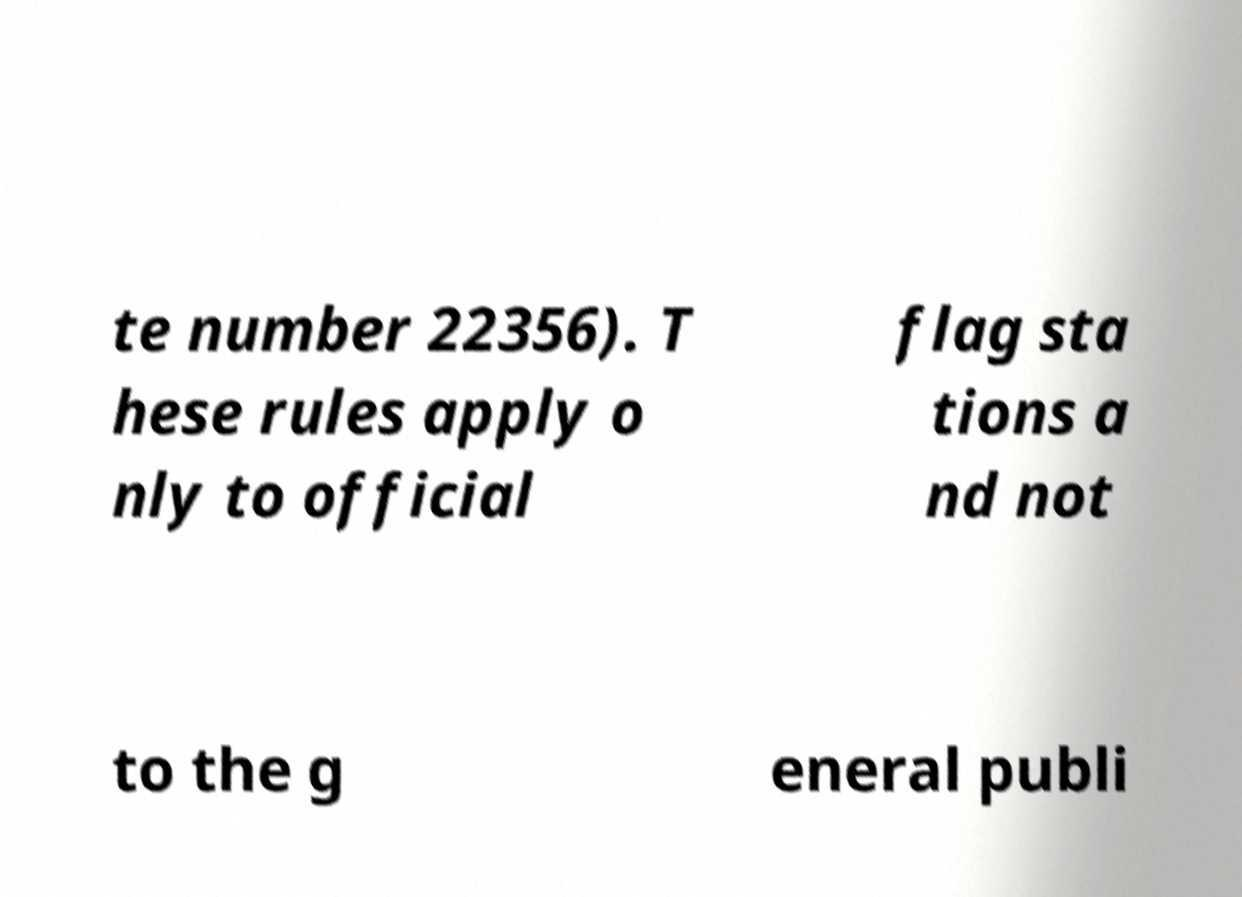For documentation purposes, I need the text within this image transcribed. Could you provide that? te number 22356). T hese rules apply o nly to official flag sta tions a nd not to the g eneral publi 